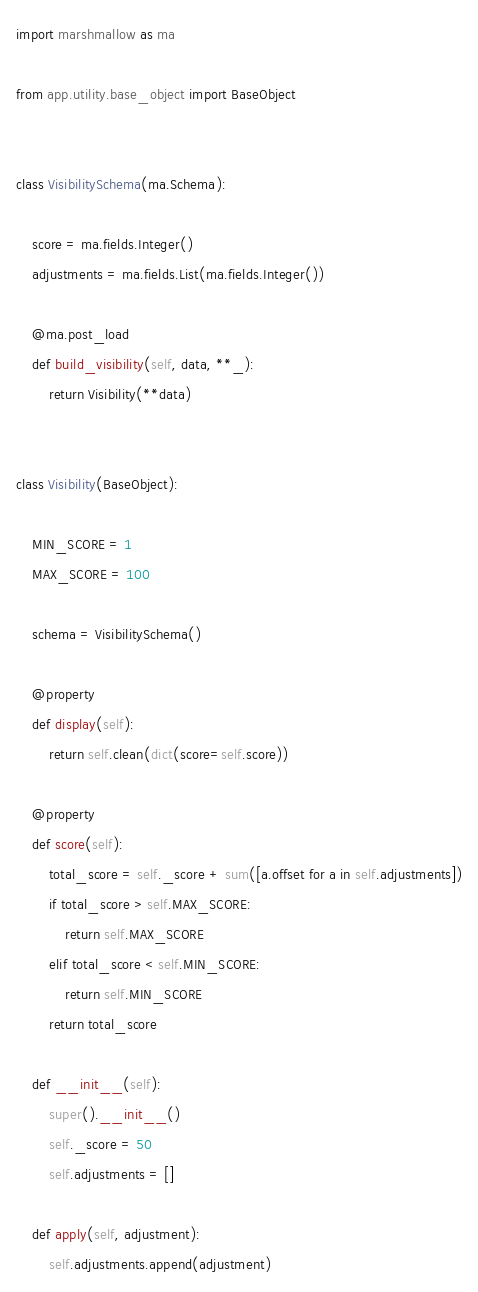Convert code to text. <code><loc_0><loc_0><loc_500><loc_500><_Python_>import marshmallow as ma

from app.utility.base_object import BaseObject


class VisibilitySchema(ma.Schema):

    score = ma.fields.Integer()
    adjustments = ma.fields.List(ma.fields.Integer())

    @ma.post_load
    def build_visibility(self, data, **_):
        return Visibility(**data)


class Visibility(BaseObject):

    MIN_SCORE = 1
    MAX_SCORE = 100

    schema = VisibilitySchema()

    @property
    def display(self):
        return self.clean(dict(score=self.score))

    @property
    def score(self):
        total_score = self._score + sum([a.offset for a in self.adjustments])
        if total_score > self.MAX_SCORE:
            return self.MAX_SCORE
        elif total_score < self.MIN_SCORE:
            return self.MIN_SCORE
        return total_score

    def __init__(self):
        super().__init__()
        self._score = 50
        self.adjustments = []

    def apply(self, adjustment):
        self.adjustments.append(adjustment)
</code> 